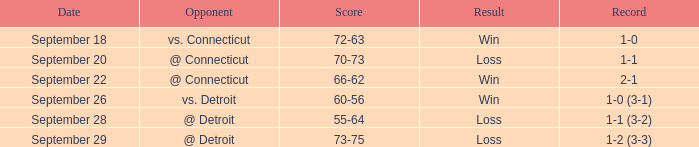What is the consequence with a score of 70-73? Loss. 